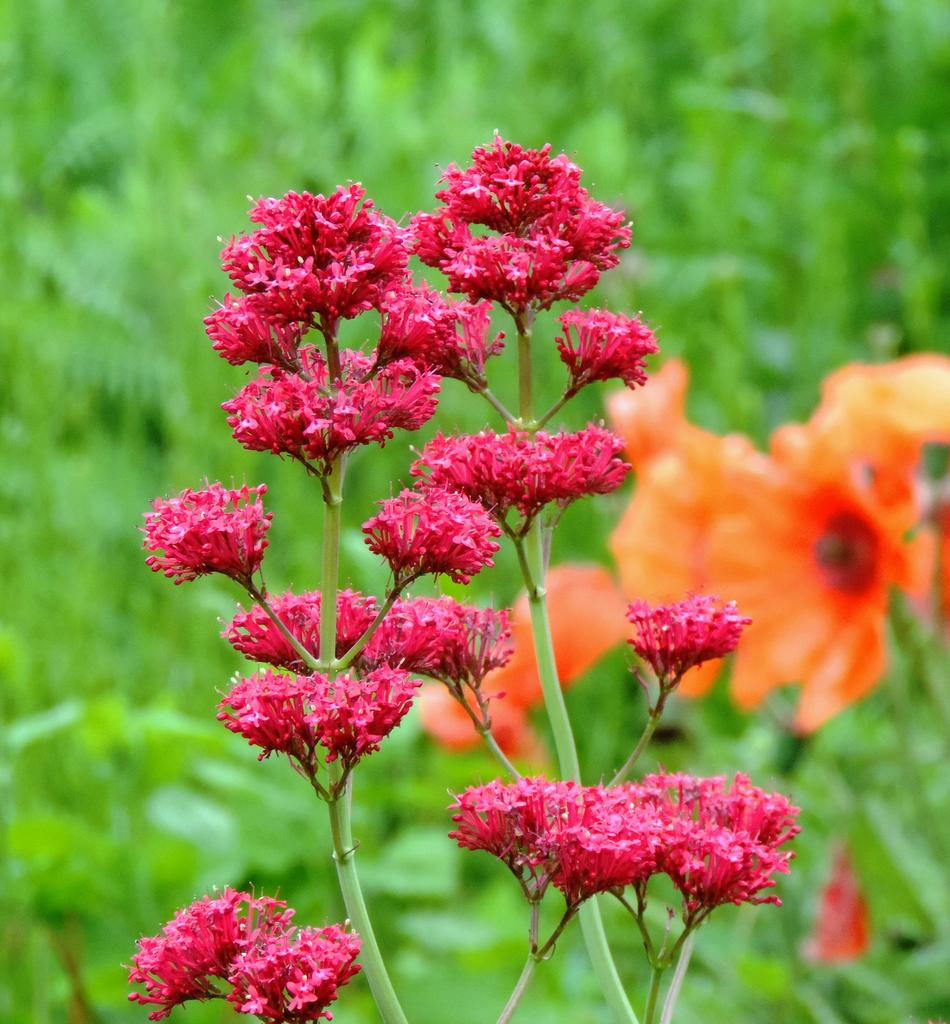What type of plants can be seen in the image? There are flowering plants in the image. What colors are present in the flowering plants? The plants have red and orange colors. When was the image taken? The image was taken during the day. Where was the image taken? The image was taken in a garden. Can you see a fireman tending to the lettuce in the image? There is no fireman or lettuce present in the image; it features flowering plants in a garden. 